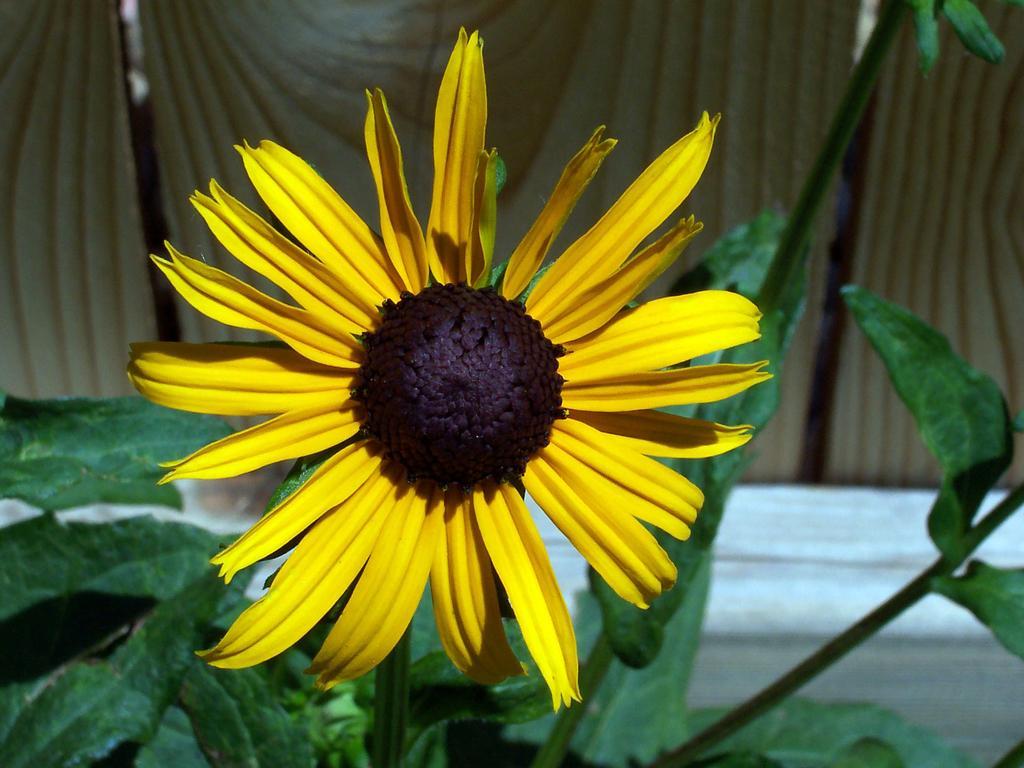Describe this image in one or two sentences. There is a flower in the center of the image, there are leaves in the background area, it seems to be there are wooden boards in the background area. 